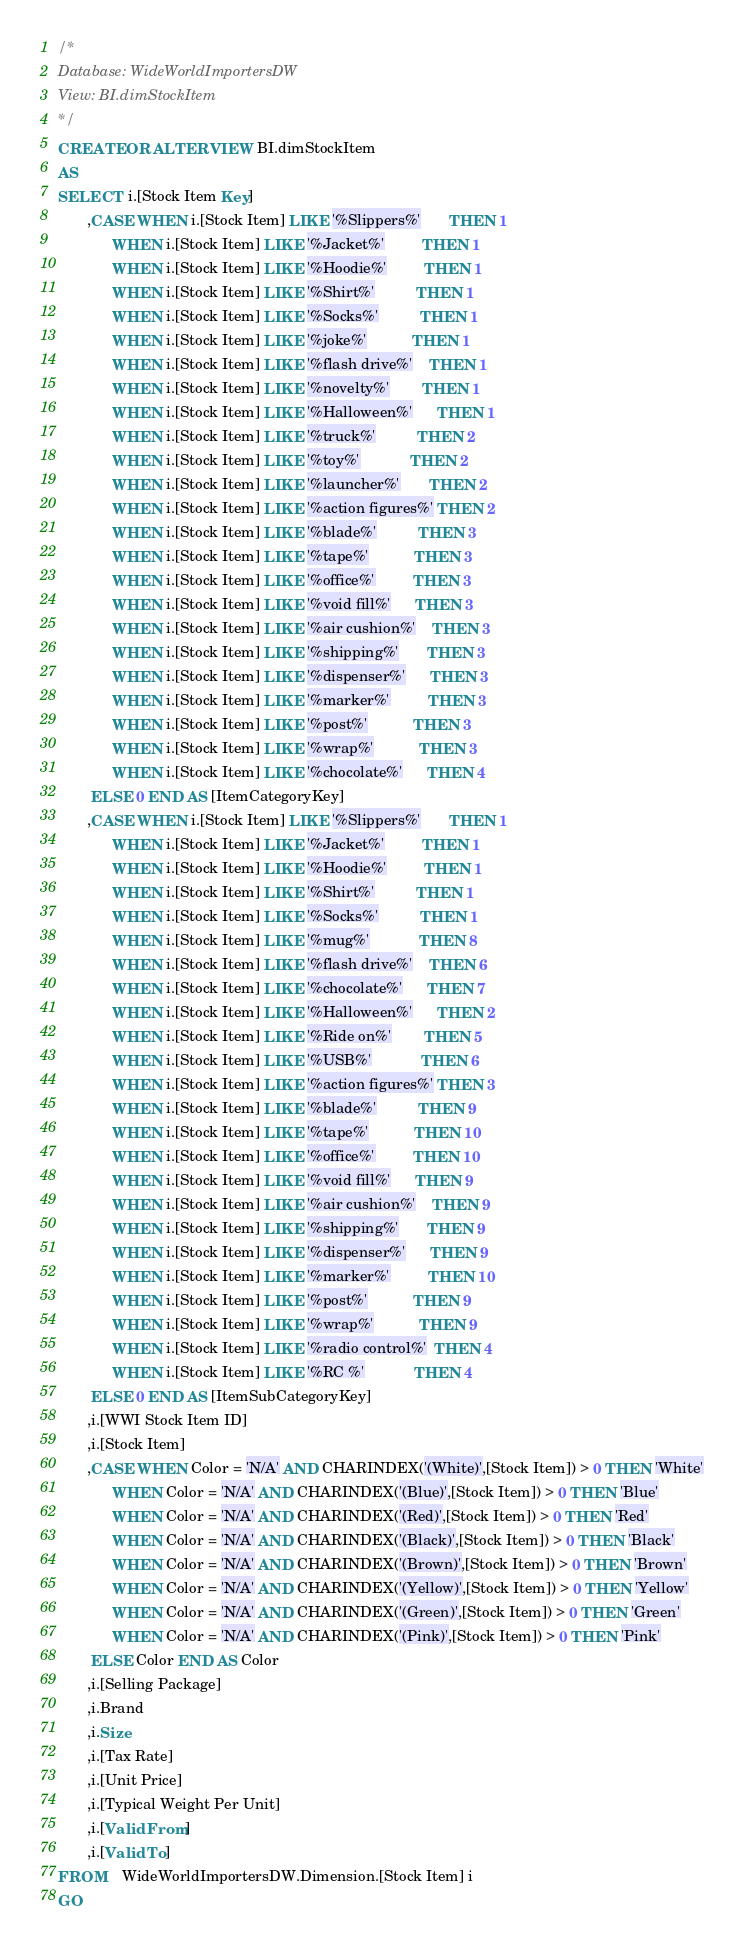Convert code to text. <code><loc_0><loc_0><loc_500><loc_500><_SQL_>/*
Database: WideWorldImportersDW
View: BI.dimStockItem
*/
CREATE OR ALTER VIEW BI.dimStockItem
AS
SELECT  i.[Stock Item Key]
       ,CASE WHEN i.[Stock Item] LIKE '%Slippers%'       THEN 1
             WHEN i.[Stock Item] LIKE '%Jacket%'         THEN 1
             WHEN i.[Stock Item] LIKE '%Hoodie%'         THEN 1
             WHEN i.[Stock Item] LIKE '%Shirt%'          THEN 1
             WHEN i.[Stock Item] LIKE '%Socks%'          THEN 1
             WHEN i.[Stock Item] LIKE '%joke%'           THEN 1
             WHEN i.[Stock Item] LIKE '%flash drive%'    THEN 1
             WHEN i.[Stock Item] LIKE '%novelty%'        THEN 1
             WHEN i.[Stock Item] LIKE '%Halloween%'      THEN 1
             WHEN i.[Stock Item] LIKE '%truck%'          THEN 2
             WHEN i.[Stock Item] LIKE '%toy%'            THEN 2
             WHEN i.[Stock Item] LIKE '%launcher%'       THEN 2
             WHEN i.[Stock Item] LIKE '%action figures%' THEN 2
             WHEN i.[Stock Item] LIKE '%blade%'          THEN 3
             WHEN i.[Stock Item] LIKE '%tape%'           THEN 3
             WHEN i.[Stock Item] LIKE '%office%'         THEN 3
             WHEN i.[Stock Item] LIKE '%void fill%'      THEN 3
             WHEN i.[Stock Item] LIKE '%air cushion%'    THEN 3
             WHEN i.[Stock Item] LIKE '%shipping%'       THEN 3
             WHEN i.[Stock Item] LIKE '%dispenser%'      THEN 3
             WHEN i.[Stock Item] LIKE '%marker%'         THEN 3
             WHEN i.[Stock Item] LIKE '%post%'           THEN 3
             WHEN i.[Stock Item] LIKE '%wrap%'           THEN 3
             WHEN i.[Stock Item] LIKE '%chocolate%'      THEN 4
        ELSE 0 END AS [ItemCategoryKey]
       ,CASE WHEN i.[Stock Item] LIKE '%Slippers%'       THEN 1
             WHEN i.[Stock Item] LIKE '%Jacket%'         THEN 1
             WHEN i.[Stock Item] LIKE '%Hoodie%'         THEN 1
             WHEN i.[Stock Item] LIKE '%Shirt%'          THEN 1
             WHEN i.[Stock Item] LIKE '%Socks%'          THEN 1
             WHEN i.[Stock Item] LIKE '%mug%'            THEN 8
             WHEN i.[Stock Item] LIKE '%flash drive%'    THEN 6
             WHEN i.[Stock Item] LIKE '%chocolate%'      THEN 7
             WHEN i.[Stock Item] LIKE '%Halloween%'      THEN 2
             WHEN i.[Stock Item] LIKE '%Ride on%'        THEN 5
             WHEN i.[Stock Item] LIKE '%USB%'            THEN 6
             WHEN i.[Stock Item] LIKE '%action figures%' THEN 3
             WHEN i.[Stock Item] LIKE '%blade%'          THEN 9
             WHEN i.[Stock Item] LIKE '%tape%'           THEN 10
             WHEN i.[Stock Item] LIKE '%office%'         THEN 10
             WHEN i.[Stock Item] LIKE '%void fill%'      THEN 9
             WHEN i.[Stock Item] LIKE '%air cushion%'    THEN 9
             WHEN i.[Stock Item] LIKE '%shipping%'       THEN 9
             WHEN i.[Stock Item] LIKE '%dispenser%'      THEN 9
             WHEN i.[Stock Item] LIKE '%marker%'         THEN 10
             WHEN i.[Stock Item] LIKE '%post%'           THEN 9
             WHEN i.[Stock Item] LIKE '%wrap%'           THEN 9
             WHEN i.[Stock Item] LIKE '%radio control%'  THEN 4
             WHEN i.[Stock Item] LIKE '%RC %'            THEN 4
        ELSE 0 END AS [ItemSubCategoryKey]
       ,i.[WWI Stock Item ID]
       ,i.[Stock Item]
       ,CASE WHEN Color = 'N/A' AND CHARINDEX('(White)',[Stock Item]) > 0 THEN 'White'
             WHEN Color = 'N/A' AND CHARINDEX('(Blue)',[Stock Item]) > 0 THEN 'Blue'
             WHEN Color = 'N/A' AND CHARINDEX('(Red)',[Stock Item]) > 0 THEN 'Red'
             WHEN Color = 'N/A' AND CHARINDEX('(Black)',[Stock Item]) > 0 THEN 'Black'
             WHEN Color = 'N/A' AND CHARINDEX('(Brown)',[Stock Item]) > 0 THEN 'Brown'
             WHEN Color = 'N/A' AND CHARINDEX('(Yellow)',[Stock Item]) > 0 THEN 'Yellow'
             WHEN Color = 'N/A' AND CHARINDEX('(Green)',[Stock Item]) > 0 THEN 'Green'
             WHEN Color = 'N/A' AND CHARINDEX('(Pink)',[Stock Item]) > 0 THEN 'Pink'
        ELSE Color END AS Color
       ,i.[Selling Package]
       ,i.Brand
       ,i.Size
       ,i.[Tax Rate]
       ,i.[Unit Price]
       ,i.[Typical Weight Per Unit]
       ,i.[Valid From]
       ,i.[Valid To]
FROM    WideWorldImportersDW.Dimension.[Stock Item] i
GO


</code> 